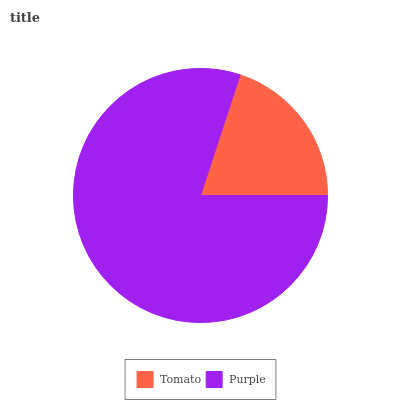Is Tomato the minimum?
Answer yes or no. Yes. Is Purple the maximum?
Answer yes or no. Yes. Is Purple the minimum?
Answer yes or no. No. Is Purple greater than Tomato?
Answer yes or no. Yes. Is Tomato less than Purple?
Answer yes or no. Yes. Is Tomato greater than Purple?
Answer yes or no. No. Is Purple less than Tomato?
Answer yes or no. No. Is Purple the high median?
Answer yes or no. Yes. Is Tomato the low median?
Answer yes or no. Yes. Is Tomato the high median?
Answer yes or no. No. Is Purple the low median?
Answer yes or no. No. 